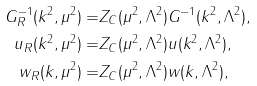<formula> <loc_0><loc_0><loc_500><loc_500>G _ { R } ^ { - 1 } ( k ^ { 2 } , \mu ^ { 2 } ) = & Z _ { C } ( \mu ^ { 2 } , \Lambda ^ { 2 } ) G ^ { - 1 } ( k ^ { 2 } , \Lambda ^ { 2 } ) , \\ u _ { R } ( k ^ { 2 } , \mu ^ { 2 } ) = & Z _ { C } ( \mu ^ { 2 } , \Lambda ^ { 2 } ) u ( k ^ { 2 } , \Lambda ^ { 2 } ) , \\ w _ { R } ( k , \mu ^ { 2 } ) = & Z _ { C } ( \mu ^ { 2 } , \Lambda ^ { 2 } ) w ( k , \Lambda ^ { 2 } ) ,</formula> 